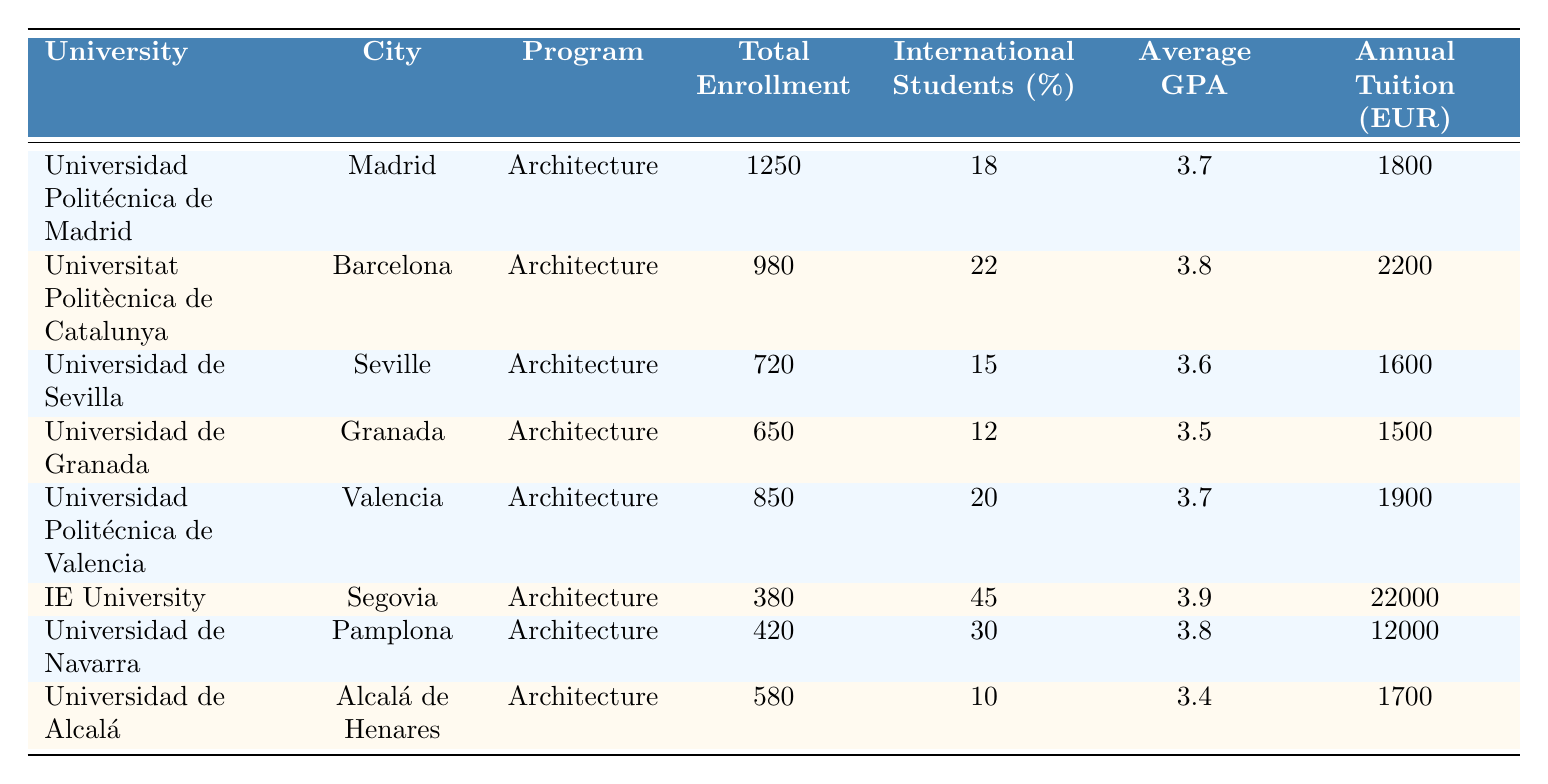What university has the highest total enrollment in architecture programs? By examining the "Total Enrollment" column, the Universidad Politécnica de Madrid has the highest value of 1250, which is greater than all other institutions listed.
Answer: Universidad Politécnica de Madrid What is the average GPA of the architecture program at the Universidad de Navarra? Referring to the table, the "Average GPA" listed for the Universidad de Navarra is 3.8.
Answer: 3.8 Which university has the highest percentage of international students? Looking at the "International Students (%)" column, IE University has the highest percentage at 45%.
Answer: IE University What is the total number of enrolled students across all universities listed? Summing the "Total Enrollment" values: 1250 + 980 + 720 + 650 + 850 + 380 + 420 + 580 = 4,730.
Answer: 4730 Is the average tuition fee at the Universidad de Granada lower than €2000? Checking the "Annual Tuition (EUR)" column, the fee for the Universidad de Granada is €1500, which is indeed lower than €2000.
Answer: Yes What is the difference in average GPA between the Universidad Politécnica de Catalunya and the Universidad de Sevilla? The average GPA for Universidad Politécnica de Catalunya is 3.8, and for Universidad de Sevilla, it is 3.6. The difference is 3.8 - 3.6 = 0.2.
Answer: 0.2 Which university, located in Valencia, has a higher average GPA than the Universidad de Alcalá? The Universidad Politécnica de Valencia has an average GPA of 3.7, while Universidad de Alcalá has 3.4. Therefore, Universidad Politécnica de Valencia has a higher GPA.
Answer: Yes If you consider only the universities with a total enrollment above 800, which has the lowest annual tuition? The universities with enrollment above 800 are Universidad Politécnica de Madrid (1800), Universitat Politècnica de Catalunya (2200), and Universidad Politécnica de Valencia (1900). Among these, Universidad Politécnica de Madrid has the lowest tuition fee of €1800.
Answer: Universidad Politécnica de Madrid What percentage of international students is found in the Universidad de Alcalá? Referring to the "International Students (%)" column, the Universidad de Alcalá has 10% international students.
Answer: 10% How many universities have annual tuition fees over €2000? Looking at the "Annual Tuition (EUR)" column, only IE University and Universidad de Navarra have fees over €2000 (22000 and 12000 respectively). This totals to 2 universities.
Answer: 2 